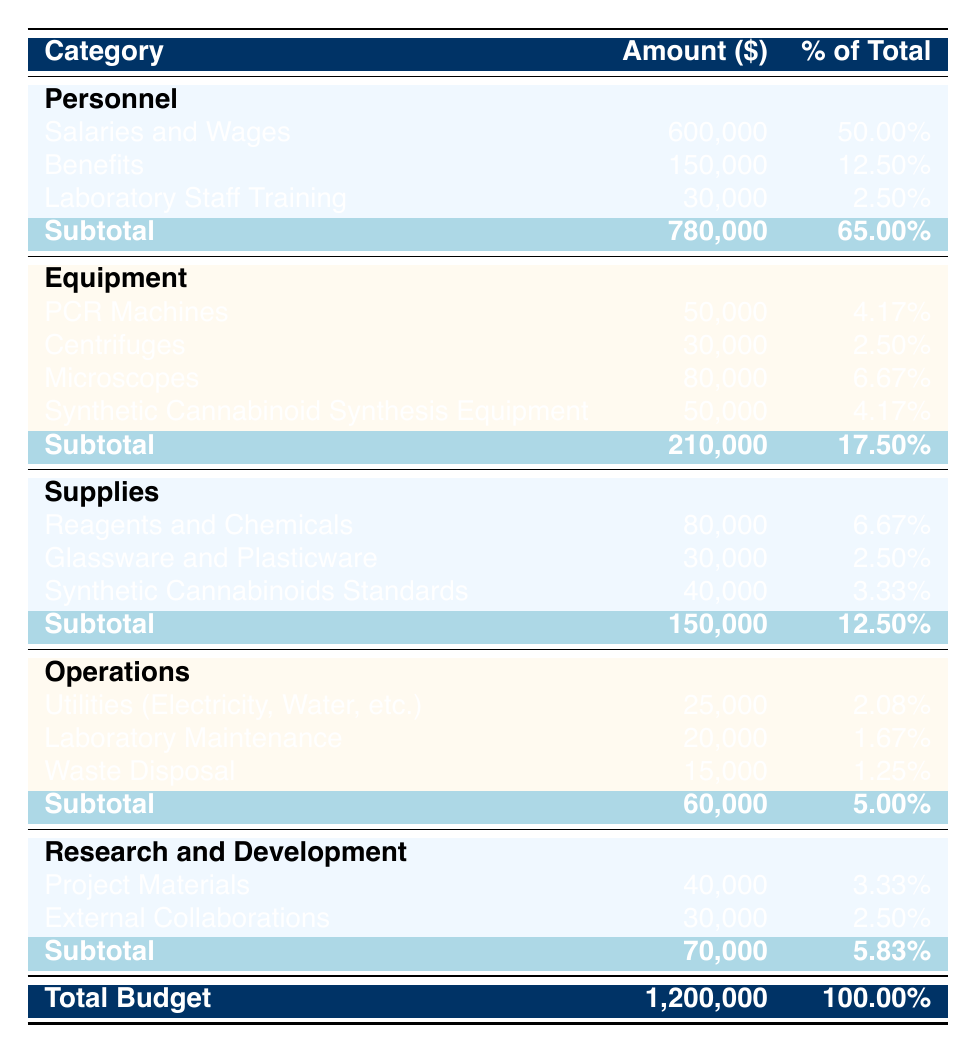What is the total budget for the Molecular Biology Laboratory in 2021? The total budget is listed at the bottom of the table under "Total Budget," which reads 1,200,000.
Answer: 1,200,000 How much was allocated for salaries and wages? The table shows that "Salaries and Wages" under the "Personnel" category amounts to 600,000.
Answer: 600,000 What percentage of the total budget is allocated to supplies? The total for supplies is 150,000, and when you calculate the percentage of the total budget (150,000 / 1,200,000) * 100, you get 12.5%.
Answer: 12.5% Is the amount for synthetic cannabinoid synthesis equipment greater than the total amount for laboratory staff training? The amount for synthetic cannabinoid synthesis equipment is 50,000 and for laboratory staff training is 30,000. Since 50,000 is greater than 30,000, the answer is yes.
Answer: Yes What is the total amount spent on operations, and how does it compare to the spending on research and development? The operations total is 60,000, while research and development totals 70,000. Comparing the two amounts shows that operations spending is less than research and development spending by 10,000.
Answer: Operations spending is less by 10,000 What is the cumulative total of expenditures for equipment? Adding the expenditures for each item under equipment: 50,000 (PCR Machines) + 30,000 (Centrifuges) + 80,000 (Microscopes) + 50,000 (Synthetic Cannabinoid Synthesis Equipment) equals 210,000.
Answer: 210,000 How much more is spent on benefits compared to waste disposal? Benefits amount to 150,000 and waste disposal amounts to 15,000. The difference is calculated as 150,000 - 15,000, which equals 135,000.
Answer: 135,000 What proportion of the total budget is allocated to personnel compared to operations? Personnel total is 780,000, and operations total is 60,000. The comparison shows that personnel occupies a significant share (780,000 / 1,200,000) * 100 which equals 65%, while operations is (60,000 / 1,200,000) * 100 which equals 5%. Thus, personnel is allocated substantially more than operations.
Answer: Personnel is 65%, operations is 5% 